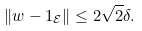<formula> <loc_0><loc_0><loc_500><loc_500>\| w - 1 _ { \mathcal { E } } \| \leq 2 \sqrt { 2 } \delta .</formula> 